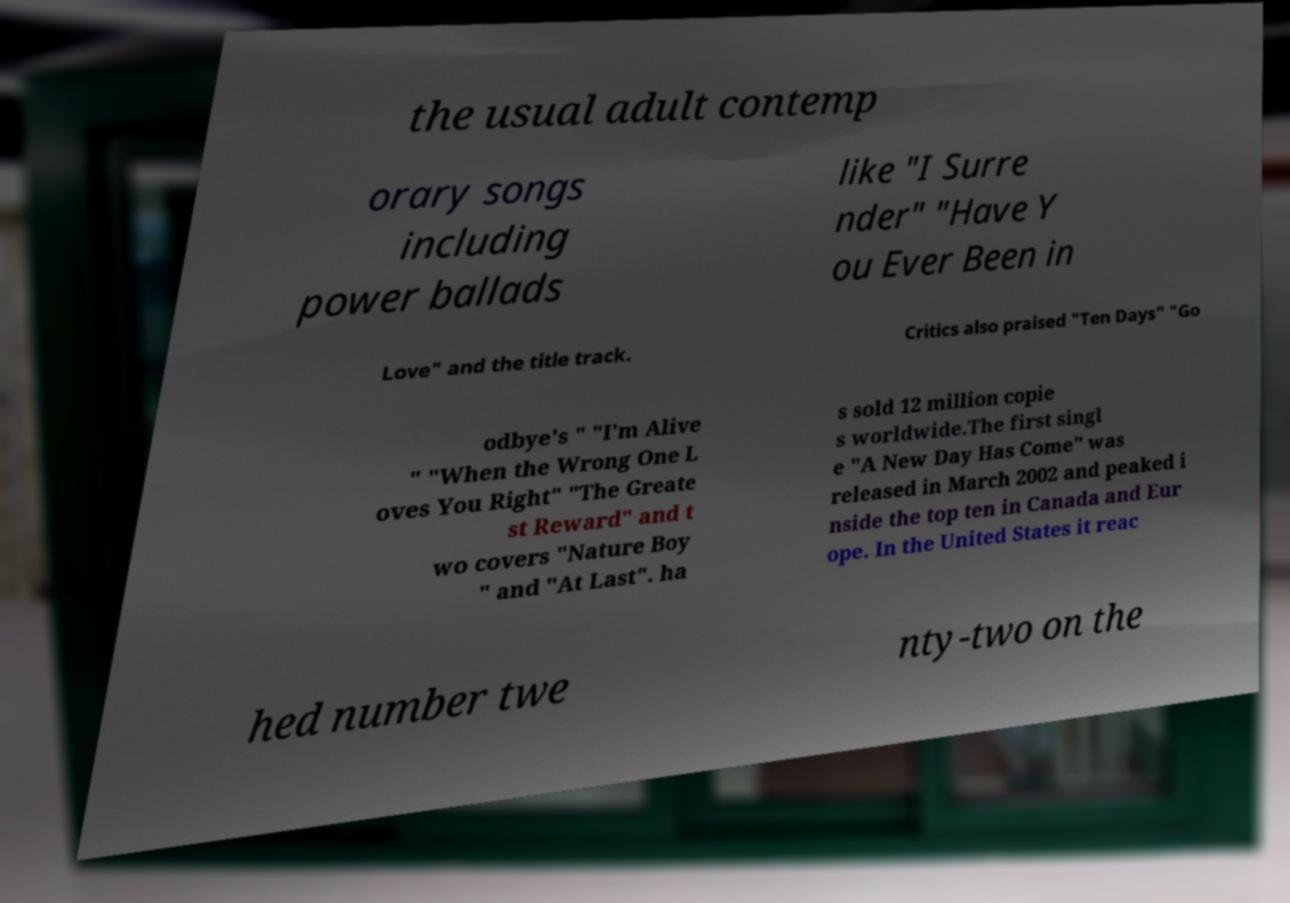Could you extract and type out the text from this image? the usual adult contemp orary songs including power ballads like "I Surre nder" "Have Y ou Ever Been in Love" and the title track. Critics also praised "Ten Days" "Go odbye's " "I'm Alive " "When the Wrong One L oves You Right" "The Greate st Reward" and t wo covers "Nature Boy " and "At Last". ha s sold 12 million copie s worldwide.The first singl e "A New Day Has Come" was released in March 2002 and peaked i nside the top ten in Canada and Eur ope. In the United States it reac hed number twe nty-two on the 